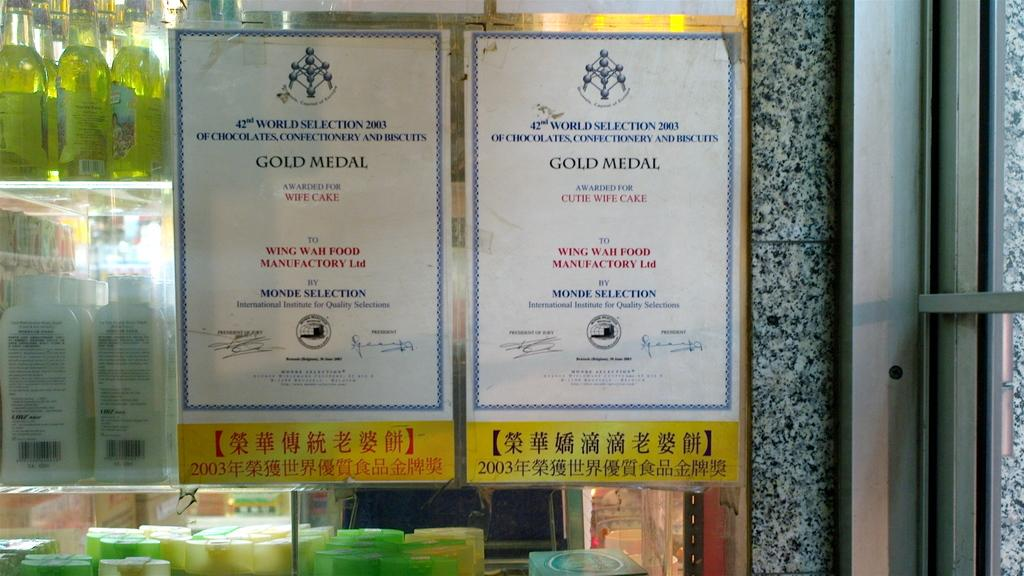Provide a one-sentence caption for the provided image. Two signs that read Gold Medal for wife cake and cute wife cake. 